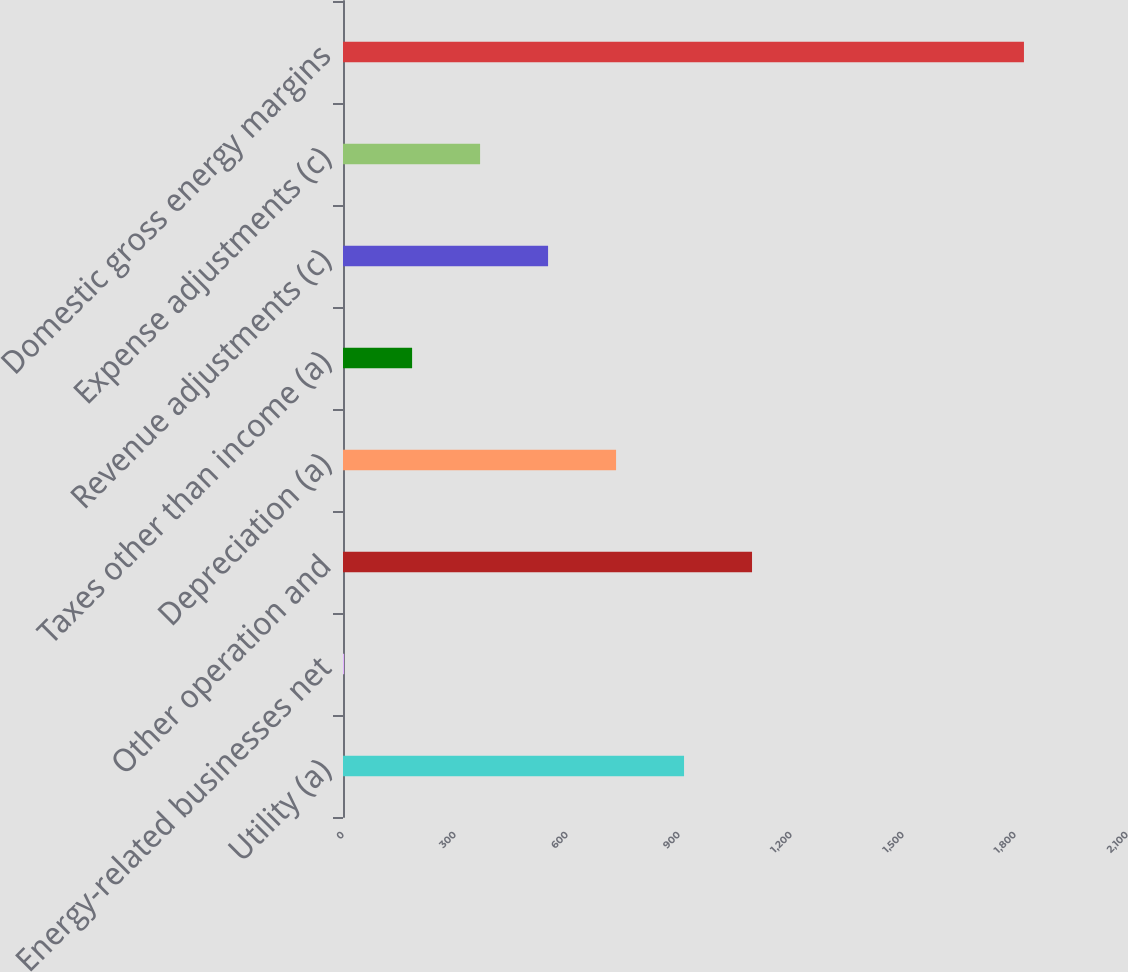<chart> <loc_0><loc_0><loc_500><loc_500><bar_chart><fcel>Utility (a)<fcel>Energy-related businesses net<fcel>Other operation and<fcel>Depreciation (a)<fcel>Taxes other than income (a)<fcel>Revenue adjustments (c)<fcel>Expense adjustments (c)<fcel>Domestic gross energy margins<nl><fcel>913.5<fcel>3<fcel>1095.6<fcel>731.4<fcel>185.1<fcel>549.3<fcel>367.2<fcel>1824<nl></chart> 